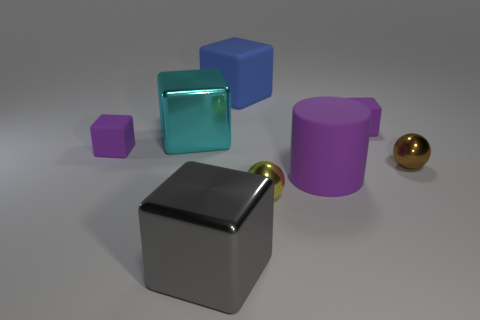What can you infer about the light source in this image? The light source in the image appears to be coming from the upper left, as evidenced by the shadows cast by the objects and the reflections seen on the glossy surfaces. 